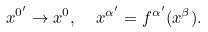Convert formula to latex. <formula><loc_0><loc_0><loc_500><loc_500>x ^ { 0 ^ { \prime } } \rightarrow x ^ { 0 } , \ \ x ^ { \alpha ^ { \prime } } = f ^ { \alpha ^ { \prime } } ( x ^ { \beta } ) .</formula> 